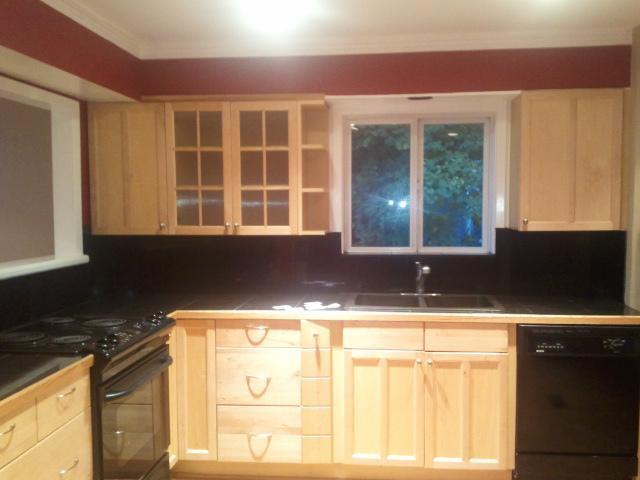How many ovens are there?
Give a very brief answer. 1. How many game remotes are pictured?
Give a very brief answer. 0. 